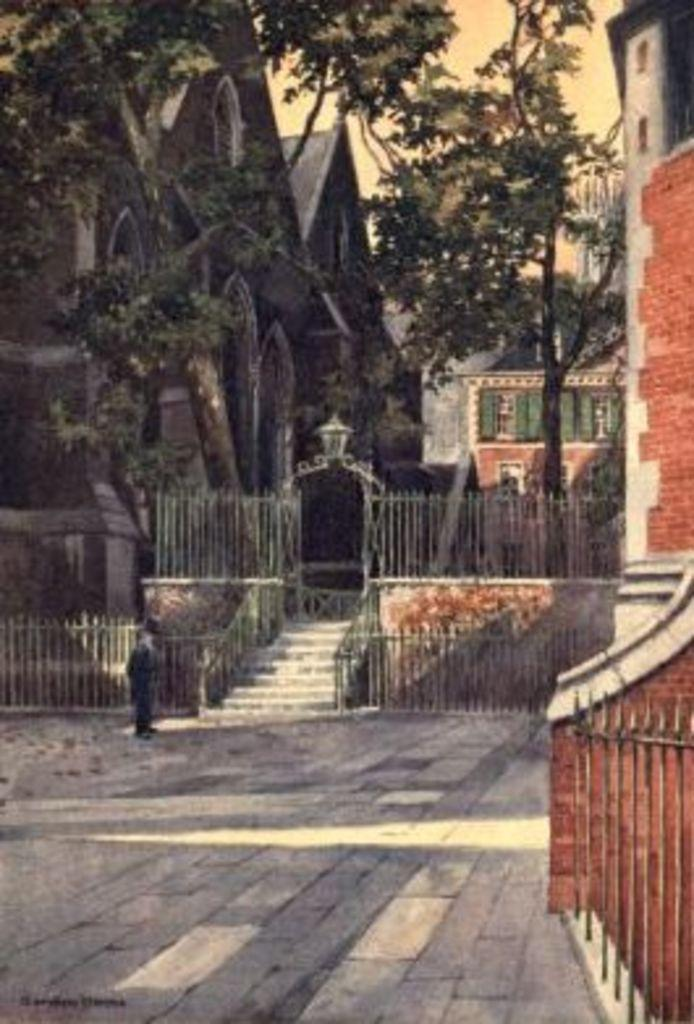What type of structures can be seen in the image? There are buildings in the image. What other natural elements are present in the image? There are trees in the image. What can be seen in the background of the image? The sky is visible in the image. Can you describe the person in the image? There is a person standing in front of a building. What type of skirt is the fireman wearing in the image? There is no fireman or skirt present in the image. What cord is connected to the trees in the image? There is no cord connected to the trees in the image. 